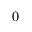Convert formula to latex. <formula><loc_0><loc_0><loc_500><loc_500>_ { 0 }</formula> 